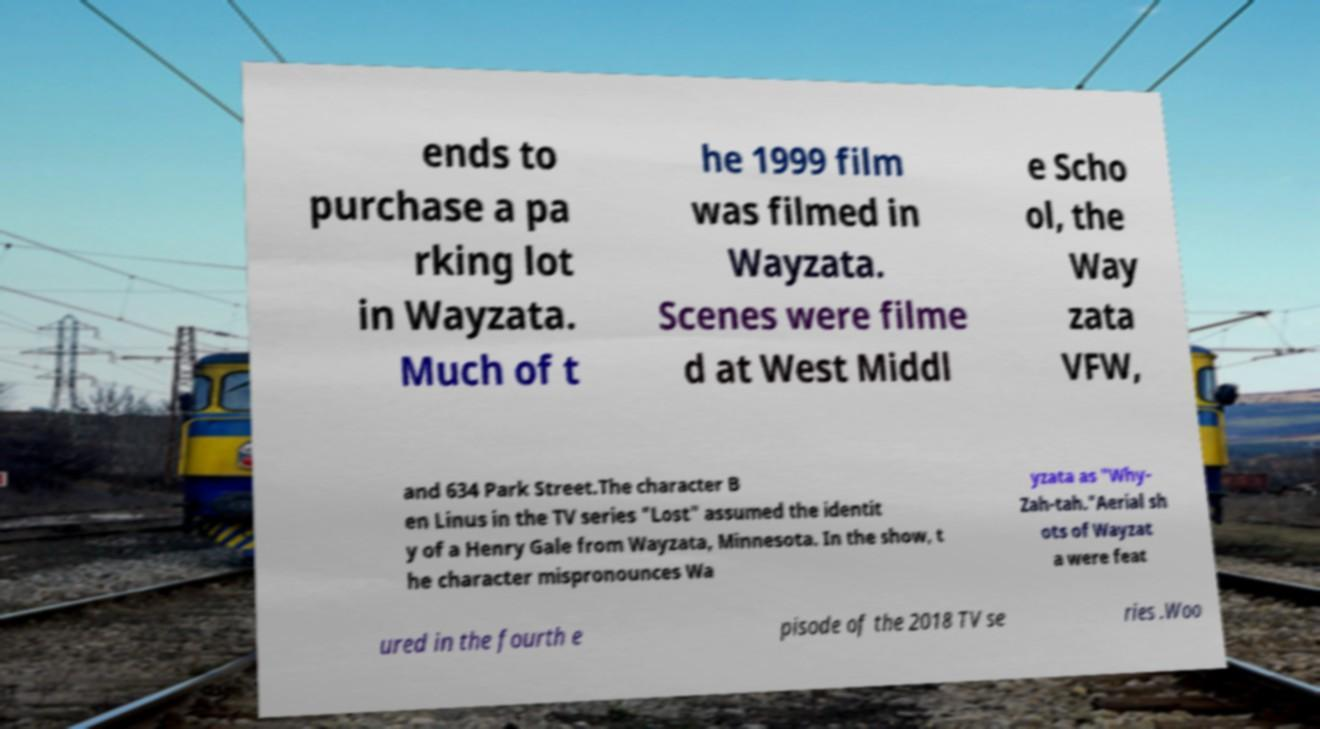Could you assist in decoding the text presented in this image and type it out clearly? ends to purchase a pa rking lot in Wayzata. Much of t he 1999 film was filmed in Wayzata. Scenes were filme d at West Middl e Scho ol, the Way zata VFW, and 634 Park Street.The character B en Linus in the TV series "Lost" assumed the identit y of a Henry Gale from Wayzata, Minnesota. In the show, t he character mispronounces Wa yzata as "Why- Zah-tah."Aerial sh ots of Wayzat a were feat ured in the fourth e pisode of the 2018 TV se ries .Woo 